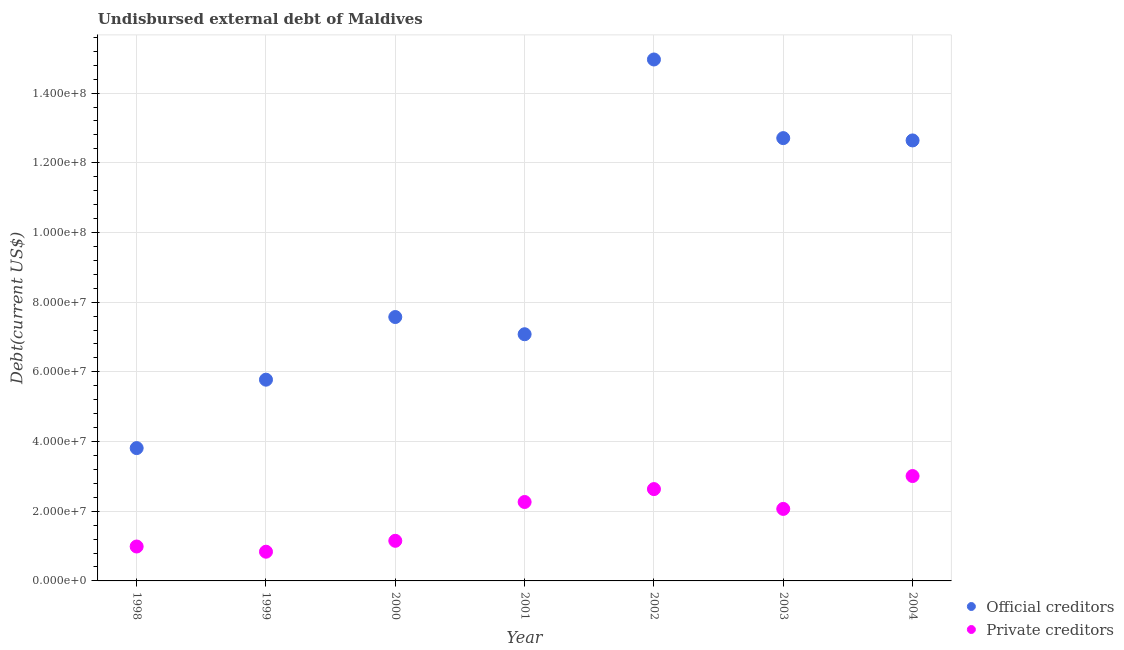Is the number of dotlines equal to the number of legend labels?
Offer a terse response. Yes. What is the undisbursed external debt of private creditors in 2003?
Your answer should be compact. 2.07e+07. Across all years, what is the maximum undisbursed external debt of private creditors?
Make the answer very short. 3.01e+07. Across all years, what is the minimum undisbursed external debt of private creditors?
Offer a terse response. 8.38e+06. In which year was the undisbursed external debt of private creditors maximum?
Offer a terse response. 2004. In which year was the undisbursed external debt of official creditors minimum?
Ensure brevity in your answer.  1998. What is the total undisbursed external debt of official creditors in the graph?
Your answer should be very brief. 6.46e+08. What is the difference between the undisbursed external debt of official creditors in 1998 and that in 2004?
Provide a succinct answer. -8.83e+07. What is the difference between the undisbursed external debt of official creditors in 1999 and the undisbursed external debt of private creditors in 2004?
Provide a short and direct response. 2.77e+07. What is the average undisbursed external debt of official creditors per year?
Ensure brevity in your answer.  9.22e+07. In the year 2004, what is the difference between the undisbursed external debt of official creditors and undisbursed external debt of private creditors?
Provide a succinct answer. 9.63e+07. In how many years, is the undisbursed external debt of private creditors greater than 152000000 US$?
Offer a very short reply. 0. What is the ratio of the undisbursed external debt of private creditors in 2002 to that in 2004?
Your response must be concise. 0.88. Is the undisbursed external debt of official creditors in 1998 less than that in 2002?
Your response must be concise. Yes. Is the difference between the undisbursed external debt of official creditors in 1998 and 2004 greater than the difference between the undisbursed external debt of private creditors in 1998 and 2004?
Make the answer very short. No. What is the difference between the highest and the second highest undisbursed external debt of official creditors?
Your response must be concise. 2.26e+07. What is the difference between the highest and the lowest undisbursed external debt of private creditors?
Make the answer very short. 2.17e+07. Is the sum of the undisbursed external debt of private creditors in 2001 and 2004 greater than the maximum undisbursed external debt of official creditors across all years?
Ensure brevity in your answer.  No. Is the undisbursed external debt of private creditors strictly greater than the undisbursed external debt of official creditors over the years?
Your answer should be compact. No. Is the undisbursed external debt of private creditors strictly less than the undisbursed external debt of official creditors over the years?
Your response must be concise. Yes. How many years are there in the graph?
Provide a short and direct response. 7. Does the graph contain grids?
Offer a very short reply. Yes. Where does the legend appear in the graph?
Provide a short and direct response. Bottom right. What is the title of the graph?
Your answer should be compact. Undisbursed external debt of Maldives. What is the label or title of the Y-axis?
Ensure brevity in your answer.  Debt(current US$). What is the Debt(current US$) of Official creditors in 1998?
Your response must be concise. 3.81e+07. What is the Debt(current US$) of Private creditors in 1998?
Your response must be concise. 9.88e+06. What is the Debt(current US$) in Official creditors in 1999?
Offer a terse response. 5.78e+07. What is the Debt(current US$) of Private creditors in 1999?
Give a very brief answer. 8.38e+06. What is the Debt(current US$) of Official creditors in 2000?
Your response must be concise. 7.57e+07. What is the Debt(current US$) of Private creditors in 2000?
Keep it short and to the point. 1.15e+07. What is the Debt(current US$) of Official creditors in 2001?
Your response must be concise. 7.08e+07. What is the Debt(current US$) of Private creditors in 2001?
Offer a terse response. 2.27e+07. What is the Debt(current US$) of Official creditors in 2002?
Your answer should be very brief. 1.50e+08. What is the Debt(current US$) of Private creditors in 2002?
Offer a terse response. 2.64e+07. What is the Debt(current US$) in Official creditors in 2003?
Provide a succinct answer. 1.27e+08. What is the Debt(current US$) of Private creditors in 2003?
Ensure brevity in your answer.  2.07e+07. What is the Debt(current US$) of Official creditors in 2004?
Offer a terse response. 1.26e+08. What is the Debt(current US$) in Private creditors in 2004?
Your response must be concise. 3.01e+07. Across all years, what is the maximum Debt(current US$) of Official creditors?
Give a very brief answer. 1.50e+08. Across all years, what is the maximum Debt(current US$) of Private creditors?
Give a very brief answer. 3.01e+07. Across all years, what is the minimum Debt(current US$) of Official creditors?
Your response must be concise. 3.81e+07. Across all years, what is the minimum Debt(current US$) of Private creditors?
Give a very brief answer. 8.38e+06. What is the total Debt(current US$) in Official creditors in the graph?
Offer a very short reply. 6.46e+08. What is the total Debt(current US$) in Private creditors in the graph?
Make the answer very short. 1.30e+08. What is the difference between the Debt(current US$) of Official creditors in 1998 and that in 1999?
Your response must be concise. -1.96e+07. What is the difference between the Debt(current US$) in Private creditors in 1998 and that in 1999?
Provide a short and direct response. 1.49e+06. What is the difference between the Debt(current US$) in Official creditors in 1998 and that in 2000?
Your answer should be compact. -3.76e+07. What is the difference between the Debt(current US$) of Private creditors in 1998 and that in 2000?
Make the answer very short. -1.64e+06. What is the difference between the Debt(current US$) in Official creditors in 1998 and that in 2001?
Provide a short and direct response. -3.27e+07. What is the difference between the Debt(current US$) in Private creditors in 1998 and that in 2001?
Keep it short and to the point. -1.28e+07. What is the difference between the Debt(current US$) of Official creditors in 1998 and that in 2002?
Ensure brevity in your answer.  -1.12e+08. What is the difference between the Debt(current US$) of Private creditors in 1998 and that in 2002?
Give a very brief answer. -1.65e+07. What is the difference between the Debt(current US$) of Official creditors in 1998 and that in 2003?
Keep it short and to the point. -8.90e+07. What is the difference between the Debt(current US$) in Private creditors in 1998 and that in 2003?
Offer a very short reply. -1.08e+07. What is the difference between the Debt(current US$) in Official creditors in 1998 and that in 2004?
Ensure brevity in your answer.  -8.83e+07. What is the difference between the Debt(current US$) of Private creditors in 1998 and that in 2004?
Your answer should be compact. -2.02e+07. What is the difference between the Debt(current US$) in Official creditors in 1999 and that in 2000?
Your answer should be very brief. -1.80e+07. What is the difference between the Debt(current US$) in Private creditors in 1999 and that in 2000?
Ensure brevity in your answer.  -3.13e+06. What is the difference between the Debt(current US$) in Official creditors in 1999 and that in 2001?
Your response must be concise. -1.30e+07. What is the difference between the Debt(current US$) in Private creditors in 1999 and that in 2001?
Keep it short and to the point. -1.43e+07. What is the difference between the Debt(current US$) of Official creditors in 1999 and that in 2002?
Your answer should be very brief. -9.19e+07. What is the difference between the Debt(current US$) of Private creditors in 1999 and that in 2002?
Offer a terse response. -1.80e+07. What is the difference between the Debt(current US$) in Official creditors in 1999 and that in 2003?
Keep it short and to the point. -6.93e+07. What is the difference between the Debt(current US$) in Private creditors in 1999 and that in 2003?
Offer a terse response. -1.23e+07. What is the difference between the Debt(current US$) in Official creditors in 1999 and that in 2004?
Provide a short and direct response. -6.87e+07. What is the difference between the Debt(current US$) in Private creditors in 1999 and that in 2004?
Give a very brief answer. -2.17e+07. What is the difference between the Debt(current US$) of Official creditors in 2000 and that in 2001?
Give a very brief answer. 4.94e+06. What is the difference between the Debt(current US$) in Private creditors in 2000 and that in 2001?
Provide a succinct answer. -1.11e+07. What is the difference between the Debt(current US$) in Official creditors in 2000 and that in 2002?
Your answer should be compact. -7.39e+07. What is the difference between the Debt(current US$) of Private creditors in 2000 and that in 2002?
Offer a terse response. -1.48e+07. What is the difference between the Debt(current US$) of Official creditors in 2000 and that in 2003?
Your answer should be very brief. -5.13e+07. What is the difference between the Debt(current US$) of Private creditors in 2000 and that in 2003?
Provide a succinct answer. -9.15e+06. What is the difference between the Debt(current US$) in Official creditors in 2000 and that in 2004?
Your answer should be compact. -5.07e+07. What is the difference between the Debt(current US$) in Private creditors in 2000 and that in 2004?
Provide a succinct answer. -1.86e+07. What is the difference between the Debt(current US$) in Official creditors in 2001 and that in 2002?
Keep it short and to the point. -7.89e+07. What is the difference between the Debt(current US$) in Private creditors in 2001 and that in 2002?
Keep it short and to the point. -3.70e+06. What is the difference between the Debt(current US$) in Official creditors in 2001 and that in 2003?
Offer a very short reply. -5.63e+07. What is the difference between the Debt(current US$) in Private creditors in 2001 and that in 2003?
Your answer should be compact. 1.98e+06. What is the difference between the Debt(current US$) of Official creditors in 2001 and that in 2004?
Ensure brevity in your answer.  -5.56e+07. What is the difference between the Debt(current US$) in Private creditors in 2001 and that in 2004?
Offer a very short reply. -7.45e+06. What is the difference between the Debt(current US$) in Official creditors in 2002 and that in 2003?
Ensure brevity in your answer.  2.26e+07. What is the difference between the Debt(current US$) in Private creditors in 2002 and that in 2003?
Your answer should be very brief. 5.69e+06. What is the difference between the Debt(current US$) of Official creditors in 2002 and that in 2004?
Provide a short and direct response. 2.32e+07. What is the difference between the Debt(current US$) in Private creditors in 2002 and that in 2004?
Keep it short and to the point. -3.74e+06. What is the difference between the Debt(current US$) in Official creditors in 2003 and that in 2004?
Ensure brevity in your answer.  6.65e+05. What is the difference between the Debt(current US$) of Private creditors in 2003 and that in 2004?
Your answer should be compact. -9.43e+06. What is the difference between the Debt(current US$) in Official creditors in 1998 and the Debt(current US$) in Private creditors in 1999?
Provide a succinct answer. 2.97e+07. What is the difference between the Debt(current US$) in Official creditors in 1998 and the Debt(current US$) in Private creditors in 2000?
Your answer should be very brief. 2.66e+07. What is the difference between the Debt(current US$) of Official creditors in 1998 and the Debt(current US$) of Private creditors in 2001?
Make the answer very short. 1.55e+07. What is the difference between the Debt(current US$) in Official creditors in 1998 and the Debt(current US$) in Private creditors in 2002?
Give a very brief answer. 1.18e+07. What is the difference between the Debt(current US$) in Official creditors in 1998 and the Debt(current US$) in Private creditors in 2003?
Offer a very short reply. 1.75e+07. What is the difference between the Debt(current US$) in Official creditors in 1998 and the Debt(current US$) in Private creditors in 2004?
Offer a terse response. 8.02e+06. What is the difference between the Debt(current US$) of Official creditors in 1999 and the Debt(current US$) of Private creditors in 2000?
Your answer should be compact. 4.62e+07. What is the difference between the Debt(current US$) of Official creditors in 1999 and the Debt(current US$) of Private creditors in 2001?
Keep it short and to the point. 3.51e+07. What is the difference between the Debt(current US$) in Official creditors in 1999 and the Debt(current US$) in Private creditors in 2002?
Offer a very short reply. 3.14e+07. What is the difference between the Debt(current US$) of Official creditors in 1999 and the Debt(current US$) of Private creditors in 2003?
Keep it short and to the point. 3.71e+07. What is the difference between the Debt(current US$) of Official creditors in 1999 and the Debt(current US$) of Private creditors in 2004?
Your answer should be compact. 2.77e+07. What is the difference between the Debt(current US$) of Official creditors in 2000 and the Debt(current US$) of Private creditors in 2001?
Give a very brief answer. 5.31e+07. What is the difference between the Debt(current US$) of Official creditors in 2000 and the Debt(current US$) of Private creditors in 2002?
Your response must be concise. 4.94e+07. What is the difference between the Debt(current US$) of Official creditors in 2000 and the Debt(current US$) of Private creditors in 2003?
Make the answer very short. 5.51e+07. What is the difference between the Debt(current US$) of Official creditors in 2000 and the Debt(current US$) of Private creditors in 2004?
Ensure brevity in your answer.  4.56e+07. What is the difference between the Debt(current US$) in Official creditors in 2001 and the Debt(current US$) in Private creditors in 2002?
Provide a succinct answer. 4.44e+07. What is the difference between the Debt(current US$) of Official creditors in 2001 and the Debt(current US$) of Private creditors in 2003?
Give a very brief answer. 5.01e+07. What is the difference between the Debt(current US$) of Official creditors in 2001 and the Debt(current US$) of Private creditors in 2004?
Offer a very short reply. 4.07e+07. What is the difference between the Debt(current US$) of Official creditors in 2002 and the Debt(current US$) of Private creditors in 2003?
Offer a very short reply. 1.29e+08. What is the difference between the Debt(current US$) of Official creditors in 2002 and the Debt(current US$) of Private creditors in 2004?
Make the answer very short. 1.20e+08. What is the difference between the Debt(current US$) in Official creditors in 2003 and the Debt(current US$) in Private creditors in 2004?
Offer a very short reply. 9.70e+07. What is the average Debt(current US$) of Official creditors per year?
Offer a terse response. 9.22e+07. What is the average Debt(current US$) of Private creditors per year?
Your answer should be very brief. 1.85e+07. In the year 1998, what is the difference between the Debt(current US$) in Official creditors and Debt(current US$) in Private creditors?
Offer a very short reply. 2.82e+07. In the year 1999, what is the difference between the Debt(current US$) in Official creditors and Debt(current US$) in Private creditors?
Provide a succinct answer. 4.94e+07. In the year 2000, what is the difference between the Debt(current US$) of Official creditors and Debt(current US$) of Private creditors?
Ensure brevity in your answer.  6.42e+07. In the year 2001, what is the difference between the Debt(current US$) of Official creditors and Debt(current US$) of Private creditors?
Provide a succinct answer. 4.81e+07. In the year 2002, what is the difference between the Debt(current US$) of Official creditors and Debt(current US$) of Private creditors?
Provide a succinct answer. 1.23e+08. In the year 2003, what is the difference between the Debt(current US$) in Official creditors and Debt(current US$) in Private creditors?
Offer a terse response. 1.06e+08. In the year 2004, what is the difference between the Debt(current US$) in Official creditors and Debt(current US$) in Private creditors?
Your answer should be very brief. 9.63e+07. What is the ratio of the Debt(current US$) of Official creditors in 1998 to that in 1999?
Keep it short and to the point. 0.66. What is the ratio of the Debt(current US$) in Private creditors in 1998 to that in 1999?
Your answer should be compact. 1.18. What is the ratio of the Debt(current US$) in Official creditors in 1998 to that in 2000?
Your answer should be compact. 0.5. What is the ratio of the Debt(current US$) of Private creditors in 1998 to that in 2000?
Your answer should be very brief. 0.86. What is the ratio of the Debt(current US$) of Official creditors in 1998 to that in 2001?
Offer a very short reply. 0.54. What is the ratio of the Debt(current US$) in Private creditors in 1998 to that in 2001?
Offer a terse response. 0.44. What is the ratio of the Debt(current US$) of Official creditors in 1998 to that in 2002?
Give a very brief answer. 0.25. What is the ratio of the Debt(current US$) in Private creditors in 1998 to that in 2002?
Offer a very short reply. 0.37. What is the ratio of the Debt(current US$) in Private creditors in 1998 to that in 2003?
Give a very brief answer. 0.48. What is the ratio of the Debt(current US$) of Official creditors in 1998 to that in 2004?
Make the answer very short. 0.3. What is the ratio of the Debt(current US$) of Private creditors in 1998 to that in 2004?
Keep it short and to the point. 0.33. What is the ratio of the Debt(current US$) of Official creditors in 1999 to that in 2000?
Give a very brief answer. 0.76. What is the ratio of the Debt(current US$) of Private creditors in 1999 to that in 2000?
Keep it short and to the point. 0.73. What is the ratio of the Debt(current US$) in Official creditors in 1999 to that in 2001?
Make the answer very short. 0.82. What is the ratio of the Debt(current US$) in Private creditors in 1999 to that in 2001?
Your answer should be very brief. 0.37. What is the ratio of the Debt(current US$) in Official creditors in 1999 to that in 2002?
Keep it short and to the point. 0.39. What is the ratio of the Debt(current US$) in Private creditors in 1999 to that in 2002?
Your answer should be compact. 0.32. What is the ratio of the Debt(current US$) of Official creditors in 1999 to that in 2003?
Give a very brief answer. 0.45. What is the ratio of the Debt(current US$) of Private creditors in 1999 to that in 2003?
Give a very brief answer. 0.41. What is the ratio of the Debt(current US$) of Official creditors in 1999 to that in 2004?
Keep it short and to the point. 0.46. What is the ratio of the Debt(current US$) of Private creditors in 1999 to that in 2004?
Your response must be concise. 0.28. What is the ratio of the Debt(current US$) in Official creditors in 2000 to that in 2001?
Offer a terse response. 1.07. What is the ratio of the Debt(current US$) of Private creditors in 2000 to that in 2001?
Make the answer very short. 0.51. What is the ratio of the Debt(current US$) in Official creditors in 2000 to that in 2002?
Keep it short and to the point. 0.51. What is the ratio of the Debt(current US$) of Private creditors in 2000 to that in 2002?
Offer a terse response. 0.44. What is the ratio of the Debt(current US$) in Official creditors in 2000 to that in 2003?
Offer a terse response. 0.6. What is the ratio of the Debt(current US$) in Private creditors in 2000 to that in 2003?
Provide a succinct answer. 0.56. What is the ratio of the Debt(current US$) in Official creditors in 2000 to that in 2004?
Offer a terse response. 0.6. What is the ratio of the Debt(current US$) in Private creditors in 2000 to that in 2004?
Make the answer very short. 0.38. What is the ratio of the Debt(current US$) of Official creditors in 2001 to that in 2002?
Offer a terse response. 0.47. What is the ratio of the Debt(current US$) in Private creditors in 2001 to that in 2002?
Offer a terse response. 0.86. What is the ratio of the Debt(current US$) in Official creditors in 2001 to that in 2003?
Offer a very short reply. 0.56. What is the ratio of the Debt(current US$) in Private creditors in 2001 to that in 2003?
Your response must be concise. 1.1. What is the ratio of the Debt(current US$) of Official creditors in 2001 to that in 2004?
Your answer should be compact. 0.56. What is the ratio of the Debt(current US$) of Private creditors in 2001 to that in 2004?
Your response must be concise. 0.75. What is the ratio of the Debt(current US$) of Official creditors in 2002 to that in 2003?
Offer a terse response. 1.18. What is the ratio of the Debt(current US$) in Private creditors in 2002 to that in 2003?
Provide a succinct answer. 1.28. What is the ratio of the Debt(current US$) in Official creditors in 2002 to that in 2004?
Make the answer very short. 1.18. What is the ratio of the Debt(current US$) of Private creditors in 2002 to that in 2004?
Your response must be concise. 0.88. What is the ratio of the Debt(current US$) of Official creditors in 2003 to that in 2004?
Provide a succinct answer. 1.01. What is the ratio of the Debt(current US$) of Private creditors in 2003 to that in 2004?
Make the answer very short. 0.69. What is the difference between the highest and the second highest Debt(current US$) of Official creditors?
Your response must be concise. 2.26e+07. What is the difference between the highest and the second highest Debt(current US$) of Private creditors?
Make the answer very short. 3.74e+06. What is the difference between the highest and the lowest Debt(current US$) in Official creditors?
Keep it short and to the point. 1.12e+08. What is the difference between the highest and the lowest Debt(current US$) in Private creditors?
Keep it short and to the point. 2.17e+07. 